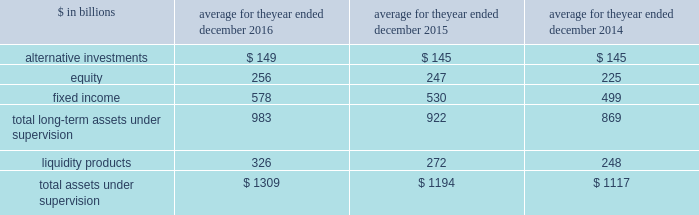The goldman sachs group , inc .
And subsidiaries management 2019s discussion and analysis 2030 total aus net inflows/ ( outflows ) for 2014 includes $ 19 billion of fixed income asset inflows in connection with our acquisition of deutsche asset & wealth management 2019s stable value business and $ 6 billion of liquidity products inflows in connection with our acquisition of rbs asset management 2019s money market funds .
The table below presents our average monthly assets under supervision by asset class .
Average for the year ended december $ in billions 2016 2015 2014 .
Operating environment .
Following a challenging first quarter of 2016 , market conditions continued to improve with higher asset prices resulting in full year appreciation in our client assets in both equity and fixed income assets .
Also , our assets under supervision increased during 2016 from net inflows , primarily in fixed income assets , and liquidity products .
The mix of our average assets under supervision shifted slightly compared with 2015 from long- term assets under supervision to liquidity products .
Management fees have been impacted by many factors , including inflows to advisory services and outflows from actively-managed mutual funds .
In the future , if asset prices decline , or investors continue the trend of favoring assets that typically generate lower fees or investors withdraw their assets , net revenues in investment management would likely be negatively impacted .
During 2015 , investment management operated in an environment generally characterized by strong client net inflows , which more than offset the declines in equity and fixed income asset prices , which resulted in depreciation in the value of client assets , particularly in the third quarter of 2015 .
The mix of average assets under supervision shifted slightly from long-term assets under supervision to liquidity products compared with 2014 .
2016 versus 2015 .
Net revenues in investment management were $ 5.79 billion for 2016 , 7% ( 7 % ) lower than 2015 .
This decrease primarily reflected significantly lower incentive fees compared with a strong 2015 .
In addition , management and other fees were slightly lower , reflecting shifts in the mix of client assets and strategies , partially offset by the impact of higher average assets under supervision .
During the year , total assets under supervision increased $ 127 billion to $ 1.38 trillion .
Long-term assets under supervision increased $ 75 billion , including net inflows of $ 42 billion , primarily in fixed income assets , and net market appreciation of $ 33 billion , primarily in equity and fixed income assets .
In addition , liquidity products increased $ 52 billion .
Operating expenses were $ 4.65 billion for 2016 , 4% ( 4 % ) lower than 2015 , due to decreased compensation and benefits expenses , reflecting lower net revenues .
Pre-tax earnings were $ 1.13 billion in 2016 , 17% ( 17 % ) lower than 2015 .
2015 versus 2014 .
Net revenues in investment management were $ 6.21 billion for 2015 , 3% ( 3 % ) higher than 2014 , due to slightly higher management and other fees , primarily reflecting higher average assets under supervision , and higher transaction revenues .
During 2015 , total assets under supervision increased $ 74 billion to $ 1.25 trillion .
Long-term assets under supervision increased $ 51 billion , including net inflows of $ 71 billion ( which includes $ 18 billion of asset inflows in connection with our acquisition of pacific global advisors 2019 solutions business ) , and net market depreciation of $ 20 billion , both primarily in fixed income and equity assets .
In addition , liquidity products increased $ 23 billion .
Operating expenses were $ 4.84 billion for 2015 , 4% ( 4 % ) higher than 2014 , due to increased compensation and benefits expenses , reflecting higher net revenues .
Pre-tax earnings were $ 1.37 billion in 2015 , 2% ( 2 % ) lower than 2014 .
Geographic data see note 25 to the consolidated financial statements for a summary of our total net revenues , pre-tax earnings and net earnings by geographic region .
Goldman sachs 2016 form 10-k 65 .
Of the total aus net inflows/ ( outflows ) for 2014 were fixed income asset inflows in connection with our acquisition of deutsche asset & wealth management 2019s stable value business greater than the liquidity products inflows in connection with our acquisition of rbs asset management 2019s money market funds? 
Computations: (19 > 6)
Answer: yes. 